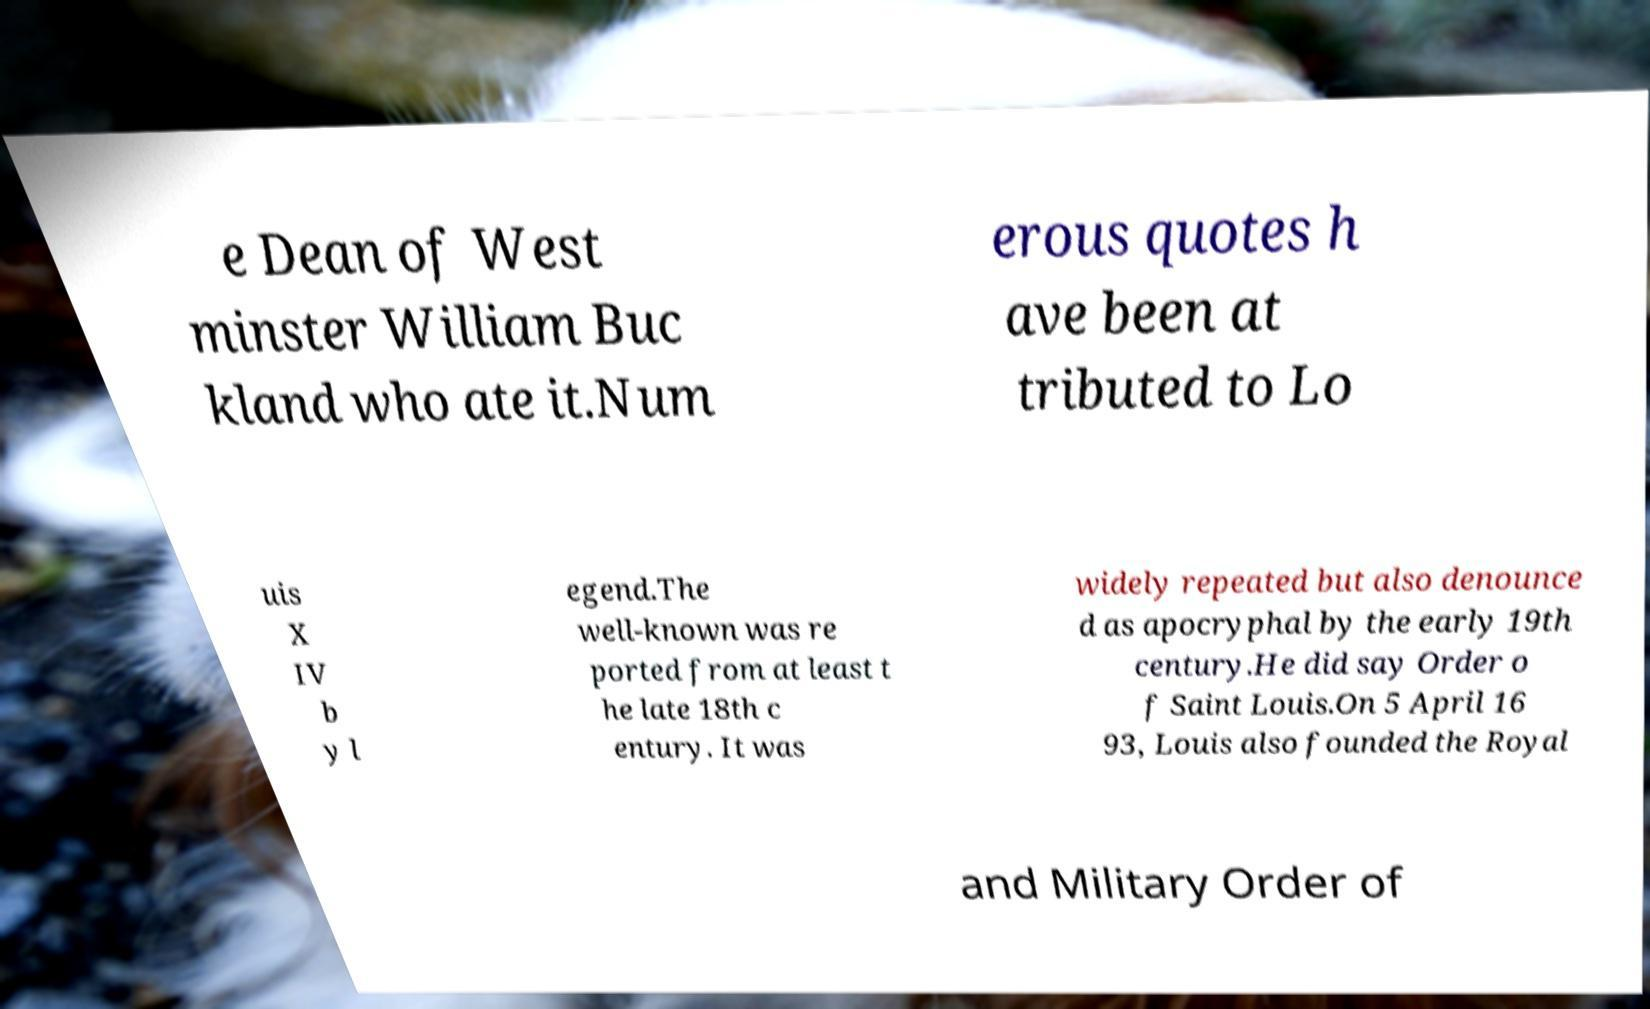Please read and relay the text visible in this image. What does it say? e Dean of West minster William Buc kland who ate it.Num erous quotes h ave been at tributed to Lo uis X IV b y l egend.The well-known was re ported from at least t he late 18th c entury. It was widely repeated but also denounce d as apocryphal by the early 19th century.He did say Order o f Saint Louis.On 5 April 16 93, Louis also founded the Royal and Military Order of 